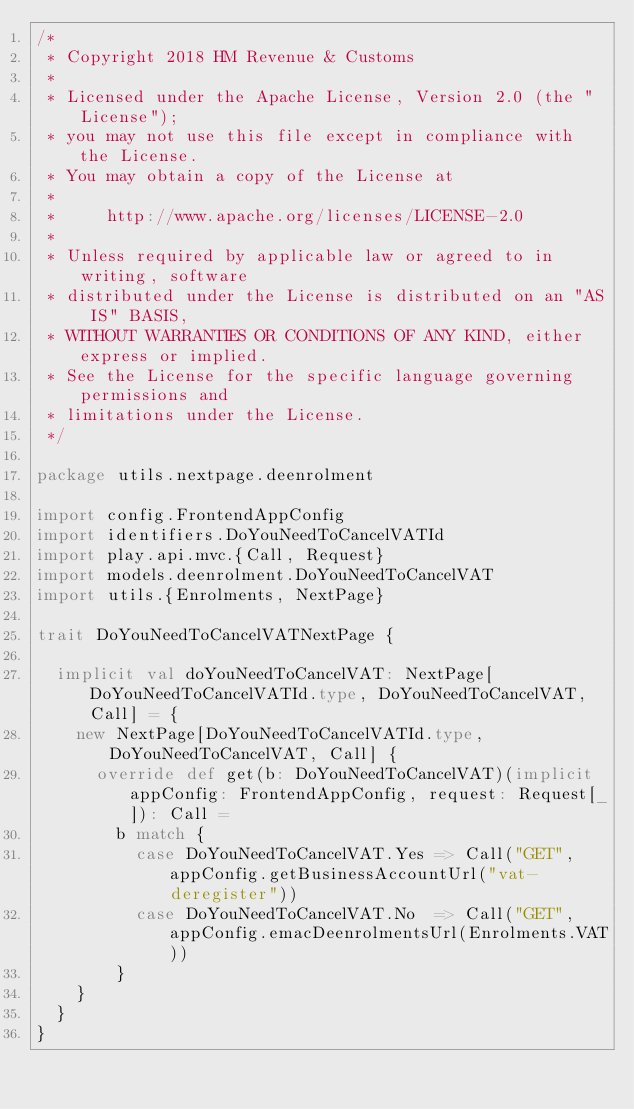<code> <loc_0><loc_0><loc_500><loc_500><_Scala_>/*
 * Copyright 2018 HM Revenue & Customs
 *
 * Licensed under the Apache License, Version 2.0 (the "License");
 * you may not use this file except in compliance with the License.
 * You may obtain a copy of the License at
 *
 *     http://www.apache.org/licenses/LICENSE-2.0
 *
 * Unless required by applicable law or agreed to in writing, software
 * distributed under the License is distributed on an "AS IS" BASIS,
 * WITHOUT WARRANTIES OR CONDITIONS OF ANY KIND, either express or implied.
 * See the License for the specific language governing permissions and
 * limitations under the License.
 */

package utils.nextpage.deenrolment

import config.FrontendAppConfig
import identifiers.DoYouNeedToCancelVATId
import play.api.mvc.{Call, Request}
import models.deenrolment.DoYouNeedToCancelVAT
import utils.{Enrolments, NextPage}

trait DoYouNeedToCancelVATNextPage {

  implicit val doYouNeedToCancelVAT: NextPage[DoYouNeedToCancelVATId.type, DoYouNeedToCancelVAT, Call] = {
    new NextPage[DoYouNeedToCancelVATId.type, DoYouNeedToCancelVAT, Call] {
      override def get(b: DoYouNeedToCancelVAT)(implicit appConfig: FrontendAppConfig, request: Request[_]): Call =
        b match {
          case DoYouNeedToCancelVAT.Yes => Call("GET", appConfig.getBusinessAccountUrl("vat-deregister"))
          case DoYouNeedToCancelVAT.No  => Call("GET", appConfig.emacDeenrolmentsUrl(Enrolments.VAT))
        }
    }
  }
}
</code> 